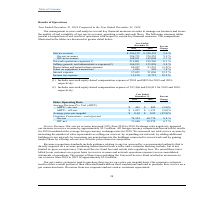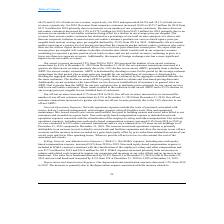From Cogent Communications Group's financial document, What are the respective amounts of non-cash equity-based compensation expense included in the network operations expenses in 2018 and 2019 respectively? The document shows two values: $895 and $994 (in thousands). From the document: "udes non-cash equity-based compensation expense of $994 and $895 for 2019 and 2018, respectively. cash equity-based compensation expense of $994 and $..." Also, What are the respective amounts of non-cash equity-based compensation expense included in the selling, general, and administrative expenses in 2018 and 2019 respectively? The document shows two values: $16,813 and $17,466 (in thousands). From the document: "udes non-cash equity-based compensation expense of $17,466 and $16,813 for 2019 and 2018, respectively. h equity-based compensation expense of $17,466..." Also, What are the respective service revenue in 2018 and 2019? The document shows two values: $520,193 and $546,159 (in thousands). From the document: "2019 2018 Change (in thousands) Service revenue $ 546,159 $ 520,193 5.0 % On - net revenues 396,753 374,555 5.9 % Off - net revenues 148,931 145,004 2..." Also, can you calculate: What is the average service revenue in 2018 and 2019? To answer this question, I need to perform calculations using the financial data. The calculation is: ($520,193 + $546,159)/2 , which equals 533176 (in thousands). This is based on the information: "Change (in thousands) Service revenue $ 546,159 $ 520,193 5.0 % On - net revenues 396,753 374,555 5.9 % Off - net revenues 148,931 145,004 2.7 % Network oper 2019 2018 Change (in thousands) Service re..." The key data points involved are: 520,193, 546,159. Also, can you calculate: What is the average on-net revenue in 2018 and 2019? To answer this question, I need to perform calculations using the financial data. The calculation is: (374,555 + 396,753)/2 , which equals 385654 (in thousands). This is based on the information: "546,159 $ 520,193 5.0 % On - net revenues 396,753 374,555 5.9 % Off - net revenues 148,931 145,004 2.7 % Network operations expenses(1) 219,801 219,526 0.1 % venue $ 546,159 $ 520,193 5.0 % On - net r..." The key data points involved are: 374,555, 396,753. Also, can you calculate: What is the average off-net revenue in 2018 and 2019? To answer this question, I need to perform calculations using the financial data. The calculation is: (145,004 + 148,931)/2 , which equals 146967.5 (in thousands). This is based on the information: "revenues 396,753 374,555 5.9 % Off - net revenues 148,931 145,004 2.7 % Network operations expenses(1) 219,801 219,526 0.1 % Selling, general, and administra 396,753 374,555 5.9 % Off - net revenues 1..." The key data points involved are: 145,004, 148,931. 